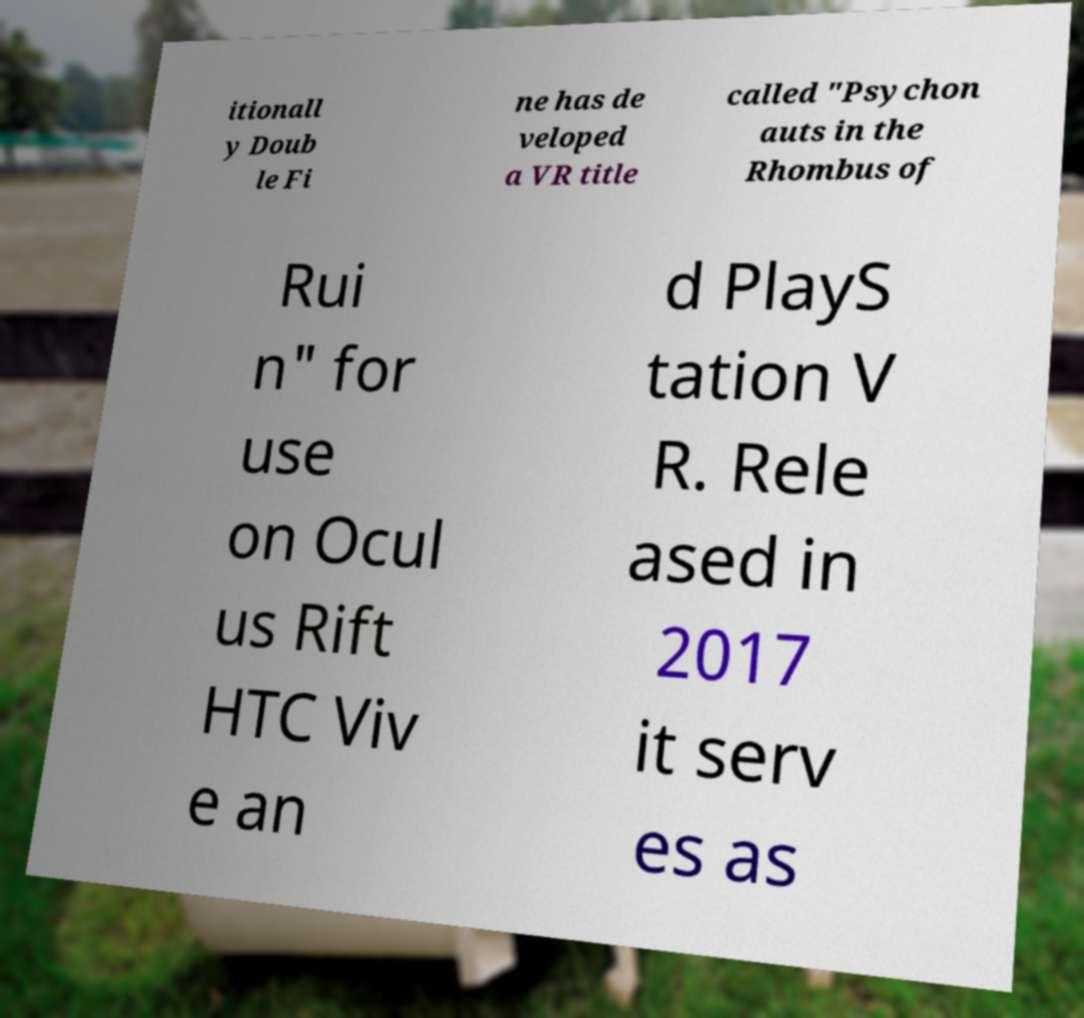Could you extract and type out the text from this image? itionall y Doub le Fi ne has de veloped a VR title called "Psychon auts in the Rhombus of Rui n" for use on Ocul us Rift HTC Viv e an d PlayS tation V R. Rele ased in 2017 it serv es as 